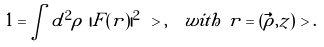Convert formula to latex. <formula><loc_0><loc_0><loc_500><loc_500>1 = & \int d ^ { 2 } \rho \ | F ( r ) | ^ { 2 } \ > , \quad w i t h \ r = ( \vec { \rho } , z ) \ > .</formula> 